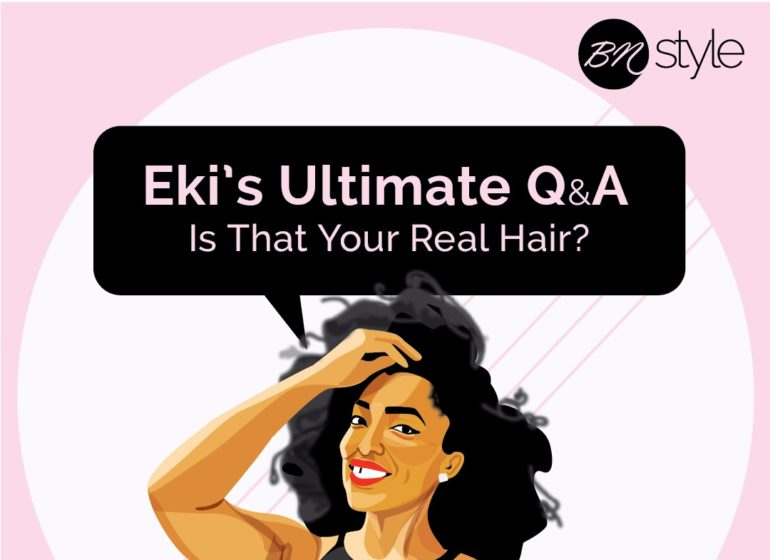Based on the visual clues provided, what could be the primary topic of discussion or content type that "Eki's Ultimate Q&A" section is likely to feature on the "BN Style" platform? "Eki's Ultimate Q&A" on the "BN Style" platform is likely to feature discussions centered around beauty and hair care, specifically focusing on natural hair. The visual clue, showing a woman gesturing towards her hair, along with the caption "Is That Your Real Hair?" suggests topics involving hair authenticity, natural beauty, and possibly tips and advice on maintaining natural hair. 